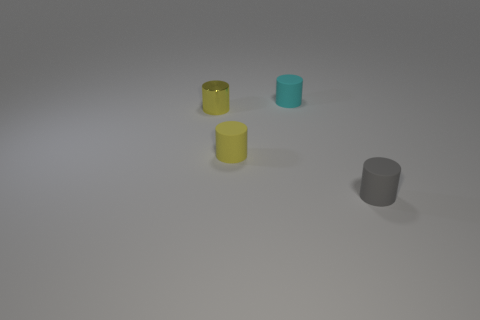Subtract all green cylinders. Subtract all cyan blocks. How many cylinders are left? 4 Add 2 big red spheres. How many objects exist? 6 Add 1 tiny yellow things. How many tiny yellow things are left? 3 Add 4 yellow metallic cylinders. How many yellow metallic cylinders exist? 5 Subtract 0 purple cubes. How many objects are left? 4 Subtract all yellow objects. Subtract all tiny metallic things. How many objects are left? 1 